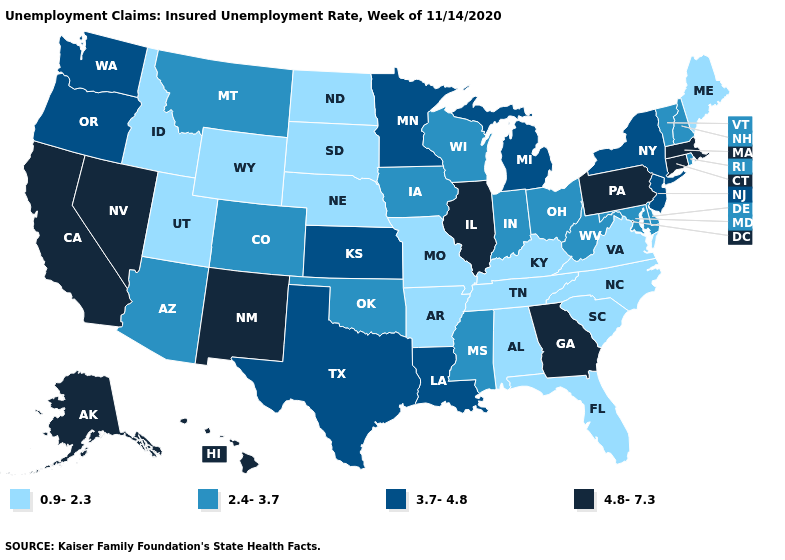Does Oregon have the same value as Utah?
Be succinct. No. What is the lowest value in states that border Rhode Island?
Write a very short answer. 4.8-7.3. How many symbols are there in the legend?
Short answer required. 4. Name the states that have a value in the range 0.9-2.3?
Answer briefly. Alabama, Arkansas, Florida, Idaho, Kentucky, Maine, Missouri, Nebraska, North Carolina, North Dakota, South Carolina, South Dakota, Tennessee, Utah, Virginia, Wyoming. Does Florida have the highest value in the South?
Short answer required. No. Does Connecticut have a higher value than Texas?
Quick response, please. Yes. Name the states that have a value in the range 0.9-2.3?
Give a very brief answer. Alabama, Arkansas, Florida, Idaho, Kentucky, Maine, Missouri, Nebraska, North Carolina, North Dakota, South Carolina, South Dakota, Tennessee, Utah, Virginia, Wyoming. Does the first symbol in the legend represent the smallest category?
Keep it brief. Yes. Among the states that border Maine , which have the highest value?
Short answer required. New Hampshire. Name the states that have a value in the range 4.8-7.3?
Be succinct. Alaska, California, Connecticut, Georgia, Hawaii, Illinois, Massachusetts, Nevada, New Mexico, Pennsylvania. What is the highest value in the USA?
Give a very brief answer. 4.8-7.3. What is the lowest value in the USA?
Give a very brief answer. 0.9-2.3. Name the states that have a value in the range 3.7-4.8?
Keep it brief. Kansas, Louisiana, Michigan, Minnesota, New Jersey, New York, Oregon, Texas, Washington. What is the value of Nevada?
Quick response, please. 4.8-7.3. Does Oklahoma have the highest value in the South?
Write a very short answer. No. 